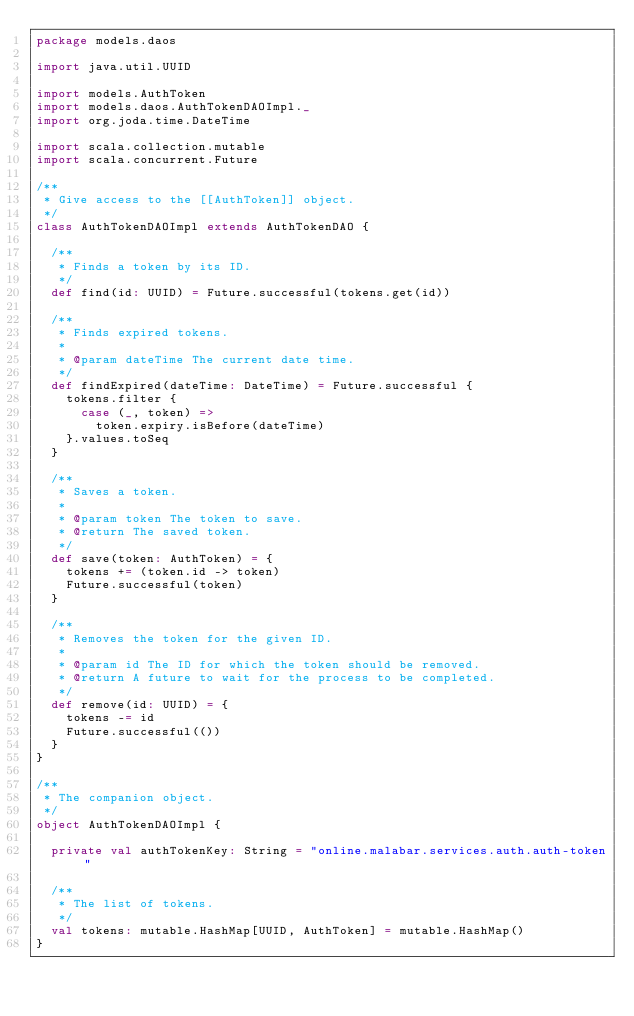Convert code to text. <code><loc_0><loc_0><loc_500><loc_500><_Scala_>package models.daos

import java.util.UUID

import models.AuthToken
import models.daos.AuthTokenDAOImpl._
import org.joda.time.DateTime

import scala.collection.mutable
import scala.concurrent.Future

/**
 * Give access to the [[AuthToken]] object.
 */
class AuthTokenDAOImpl extends AuthTokenDAO {

  /**
   * Finds a token by its ID.
   */
  def find(id: UUID) = Future.successful(tokens.get(id))

  /**
   * Finds expired tokens.
   *
   * @param dateTime The current date time.
   */
  def findExpired(dateTime: DateTime) = Future.successful {
    tokens.filter {
      case (_, token) =>
        token.expiry.isBefore(dateTime)
    }.values.toSeq
  }

  /**
   * Saves a token.
   *
   * @param token The token to save.
   * @return The saved token.
   */
  def save(token: AuthToken) = {
    tokens += (token.id -> token)
    Future.successful(token)
  }

  /**
   * Removes the token for the given ID.
   *
   * @param id The ID for which the token should be removed.
   * @return A future to wait for the process to be completed.
   */
  def remove(id: UUID) = {
    tokens -= id
    Future.successful(())
  }
}

/**
 * The companion object.
 */
object AuthTokenDAOImpl {

  private val authTokenKey: String = "online.malabar.services.auth.auth-token"

  /**
   * The list of tokens.
   */
  val tokens: mutable.HashMap[UUID, AuthToken] = mutable.HashMap()
}
</code> 